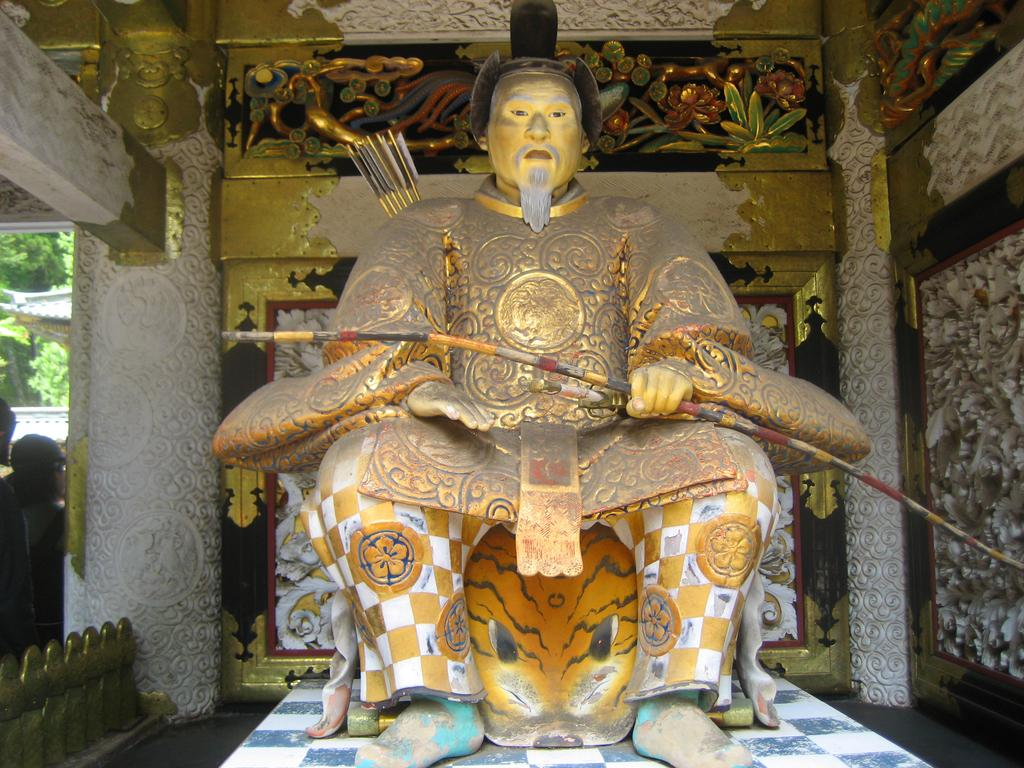What is the main subject in the middle of the image? There is a statue in the middle of the image. What can be seen in the background of the image? There are colorful walls in the background of the image. What architectural feature is located on the left side of the image? There is a pillar on the left side of the image. What note is the statue playing on the instrument in the image? There is no instrument present in the image, and therefore no note can be played by the statue. 